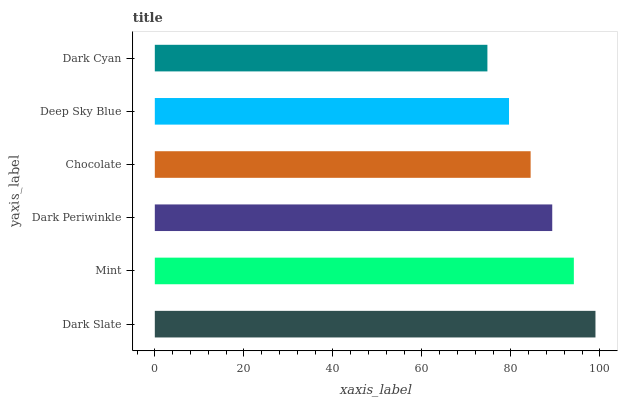Is Dark Cyan the minimum?
Answer yes or no. Yes. Is Dark Slate the maximum?
Answer yes or no. Yes. Is Mint the minimum?
Answer yes or no. No. Is Mint the maximum?
Answer yes or no. No. Is Dark Slate greater than Mint?
Answer yes or no. Yes. Is Mint less than Dark Slate?
Answer yes or no. Yes. Is Mint greater than Dark Slate?
Answer yes or no. No. Is Dark Slate less than Mint?
Answer yes or no. No. Is Dark Periwinkle the high median?
Answer yes or no. Yes. Is Chocolate the low median?
Answer yes or no. Yes. Is Dark Cyan the high median?
Answer yes or no. No. Is Mint the low median?
Answer yes or no. No. 